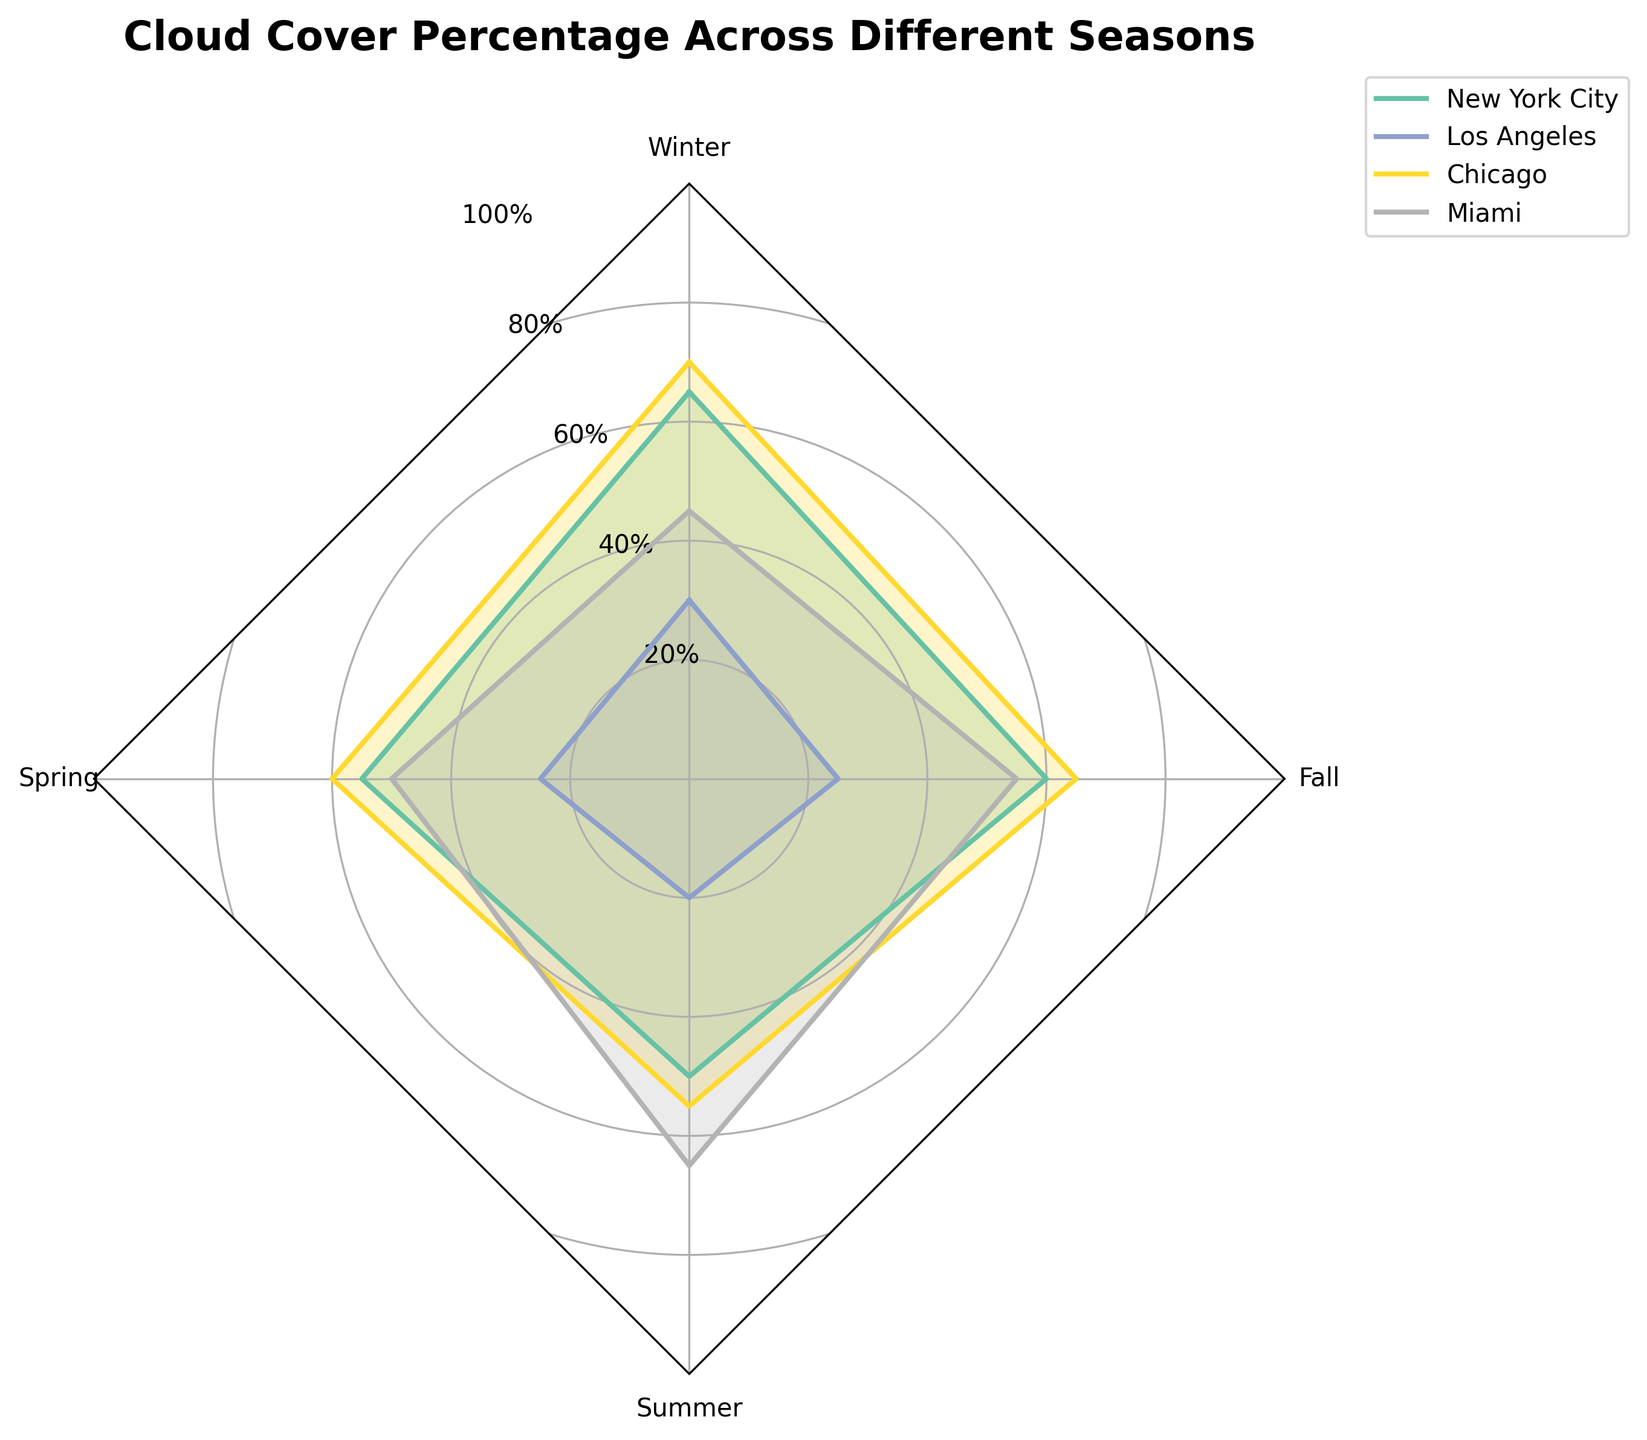How many seasons are represented in the radar chart? The radar chart shows cloud cover percentage across different seasons. We can identify the number of seasons by looking at the number of axes in the radar plot. Here, four axes are labeled with the four seasons: Winter, Spring, Summer, and Fall.
Answer: Four Which location has the highest cloud cover percentage in the Winter? The radar plot indicates the cloud cover percentages for each location across all seasons. By observing the winter axis, we see that Chicago has the highest cloud cover percentage at 70%.
Answer: Chicago How many locations have a cloud cover percentage greater than 50% in the Summer? The radar plot allows us to compare cloud cover percentages for each location during the summer. New York City (50%), Chicago (55%), and Miami (65%) all have percentages above 50%.
Answer: Three Between which seasons does Miami show the largest difference in cloud cover percentage? To find this, we must compare Miami's cloud cover percentages across all seasons: Winter (45%), Spring (50%), Summer (65%), Fall (55%). The largest change is from Winter (45%) to Summer (65%), a difference of 20%.
Answer: Winter and Summer Which season has the most uniform cloud cover percentage across all locations? By examining the radar chart, we look for the season where the cloud cover percentages for all locations are closest together. In Spring: New York City (55%), Los Angeles (25%), Chicago (60%), Miami (50%) have closer values compared to other seasons.
Answer: Spring What is the average cloud cover percentage for New York City across all seasons? We find the cloud cover percentages for New York City in each season: Winter (65%), Spring (55%), Summer (50%), and Fall (60%). Adding these: 65 + 55 + 50 + 60 = 230. Dividing by the number of seasons (4) gives 230/4 = 57.5%.
Answer: 57.5% Which location has the lowest variability in cloud cover percentage across seasons? To determine variability, we observe the differences in cloud cover percentages for each location. Los Angeles varies the least with values: Winter (30%), Spring (25%), Summer (20%), Fall (25%).
Answer: Los Angeles In which season does Los Angeles have the maximum cloud cover percentage? By looking at the radar chart, we locate the season axis and find the maximum cloud cover percentage for Los Angeles, which occurs in Winter at 30%.
Answer: Winter Are there any seasons where New York City and Chicago have the same cloud cover percentage? We compare the values for New York City and Chicago across all seasons. In Winter (65, 70), Spring (55, 60), Summer (50, 55), and Fall (60, 65), there are no matching percentages.
Answer: No Which season shows the greatest overall range in cloud cover percentage across all locations? We compute the range for each season by subtracting the minimum value from the maximum value. Winter (70-30=40), Spring (60-25=35), Summer (65-20=45), Fall (65-25=40). Summer shows the greatest range at 45.
Answer: Summer 